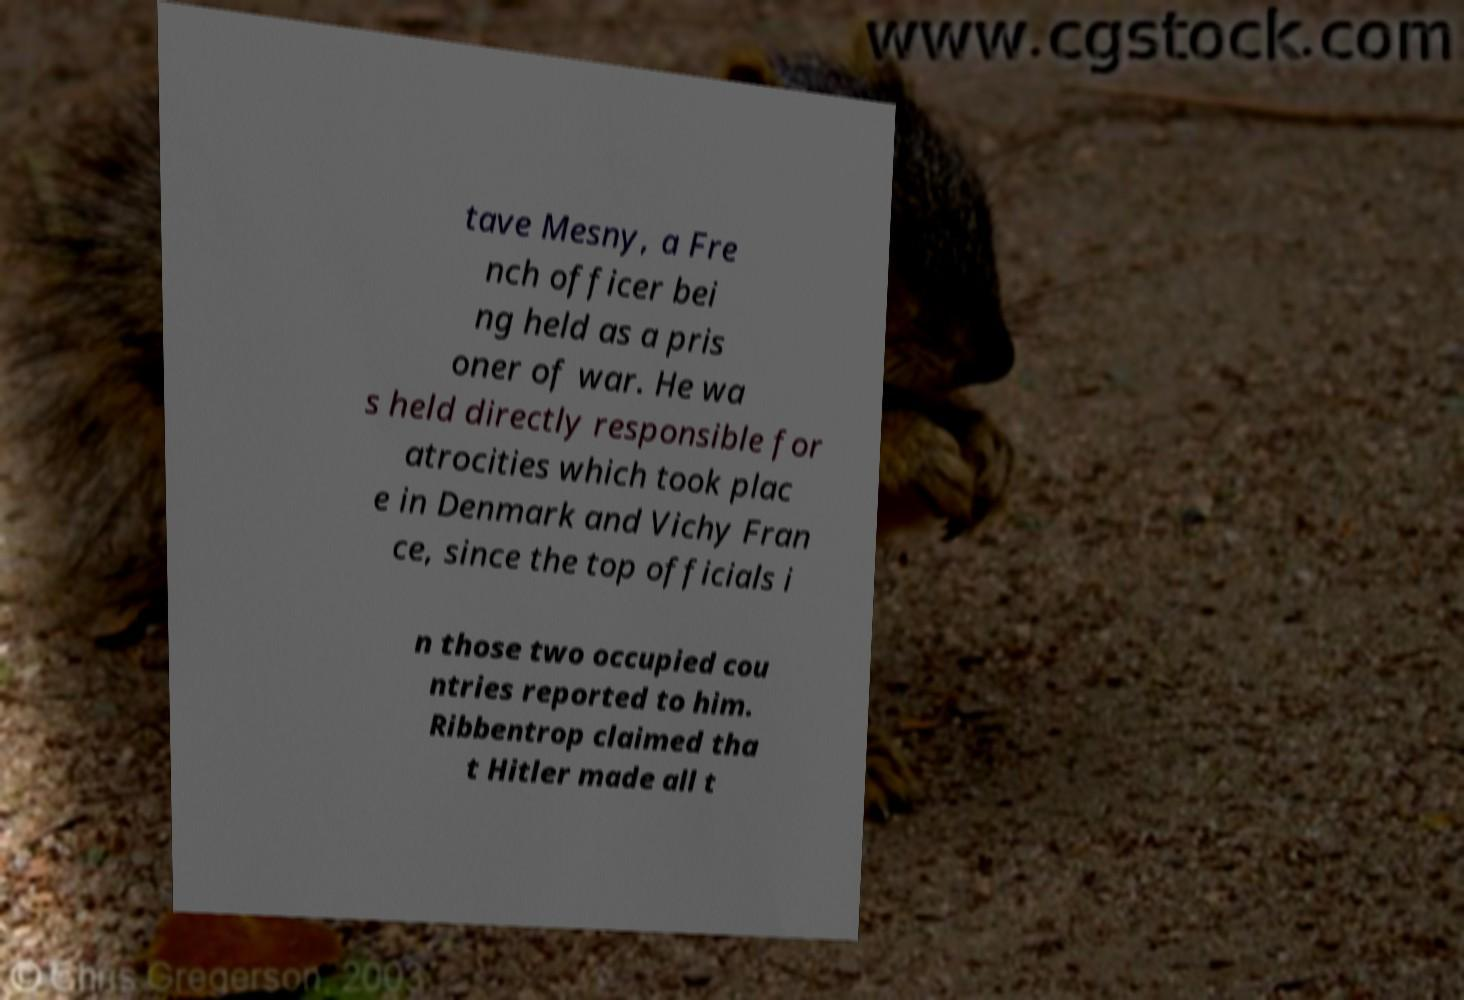Can you accurately transcribe the text from the provided image for me? tave Mesny, a Fre nch officer bei ng held as a pris oner of war. He wa s held directly responsible for atrocities which took plac e in Denmark and Vichy Fran ce, since the top officials i n those two occupied cou ntries reported to him. Ribbentrop claimed tha t Hitler made all t 